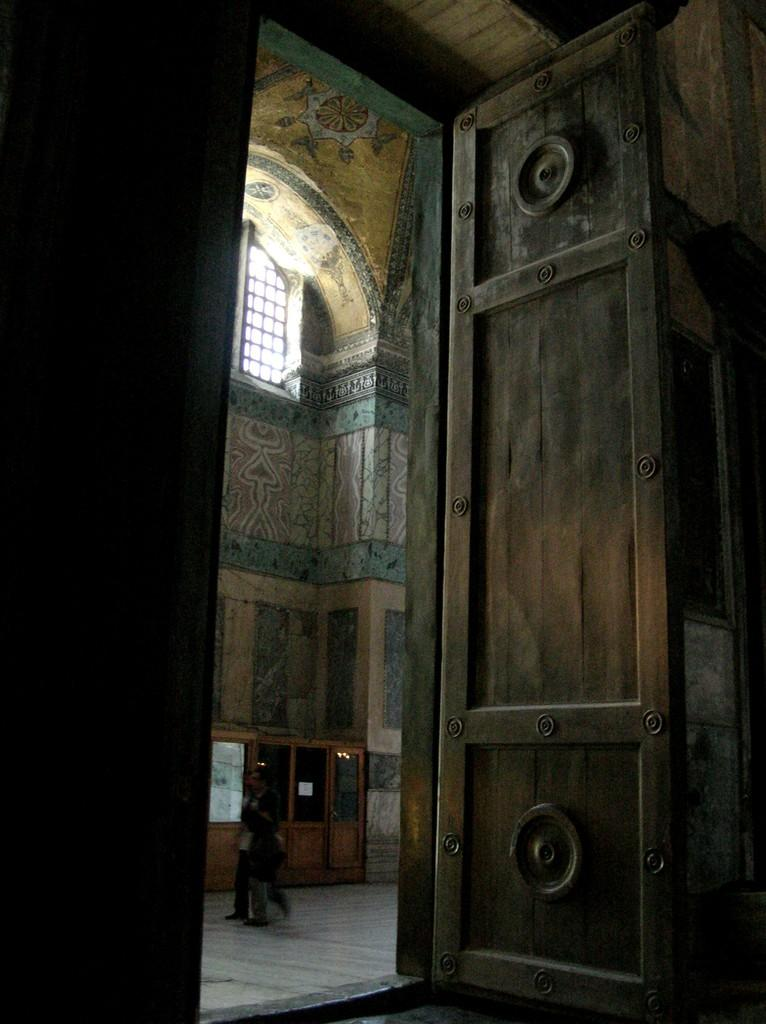How many persons are in the image? There are persons standing in the image. What surface are the persons standing on? The persons are standing on the floor. What structures are near the persons in the image? The persons are standing near a door, walls, and a window. Can you see a hill in the background of the image? There is no hill visible in the image. What part of the library are the persons standing in? There is no reference to a library in the image, so it cannot be determined where the persons are standing in relation to a library. 